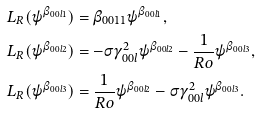<formula> <loc_0><loc_0><loc_500><loc_500>& L _ { R } ( \psi ^ { \beta _ { 0 0 l 1 } } ) = \beta _ { 0 0 1 1 } \psi ^ { \beta _ { 0 0 l 1 } } , \\ & L _ { R } ( \psi ^ { \beta _ { 0 0 l 2 } } ) = - \sigma \gamma _ { 0 0 l } ^ { 2 } \psi ^ { \beta _ { 0 0 l 2 } } - \frac { 1 } { R o } \psi ^ { \beta _ { 0 0 l 3 } } , \\ & L _ { R } ( \psi ^ { \beta _ { 0 0 l 3 } } ) = \frac { 1 } { R o } \psi ^ { \beta _ { 0 0 l 2 } } - \sigma \gamma _ { 0 0 l } ^ { 2 } \psi ^ { \beta _ { 0 0 l 3 } } .</formula> 